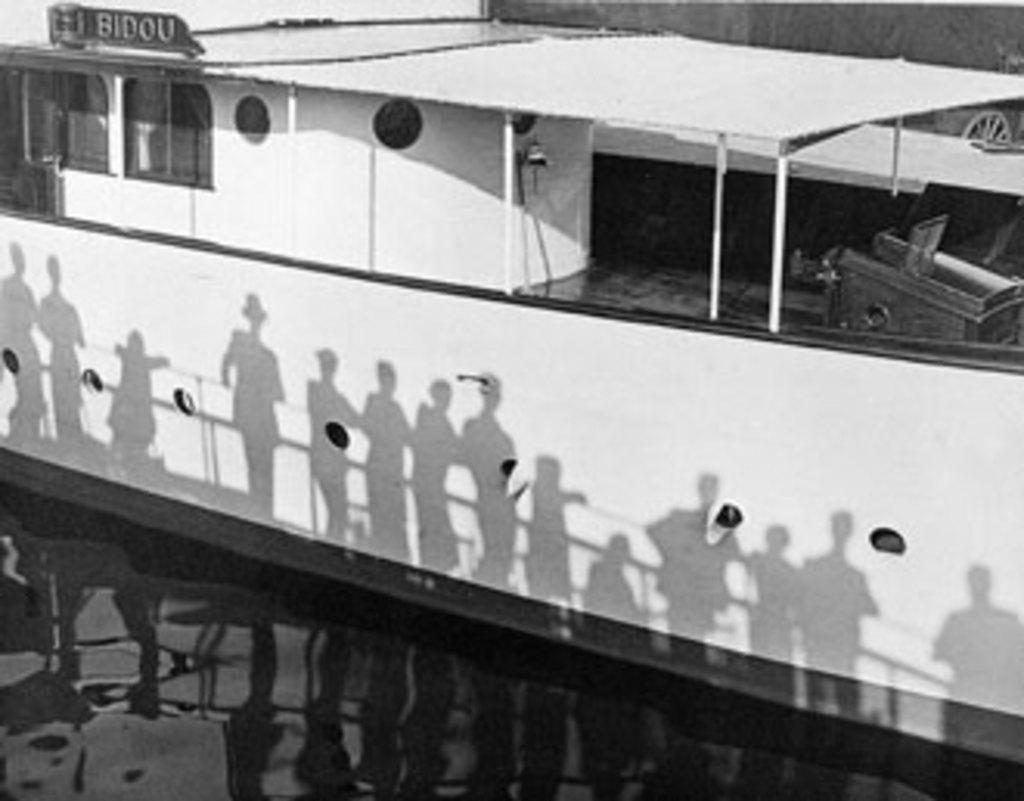<image>
Describe the image concisely. A classic image with people looking at a boat with a sign that says BIDOU. 